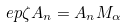Convert formula to latex. <formula><loc_0><loc_0><loc_500><loc_500>\ e p \zeta A _ { n } = A _ { n } M _ { \alpha }</formula> 